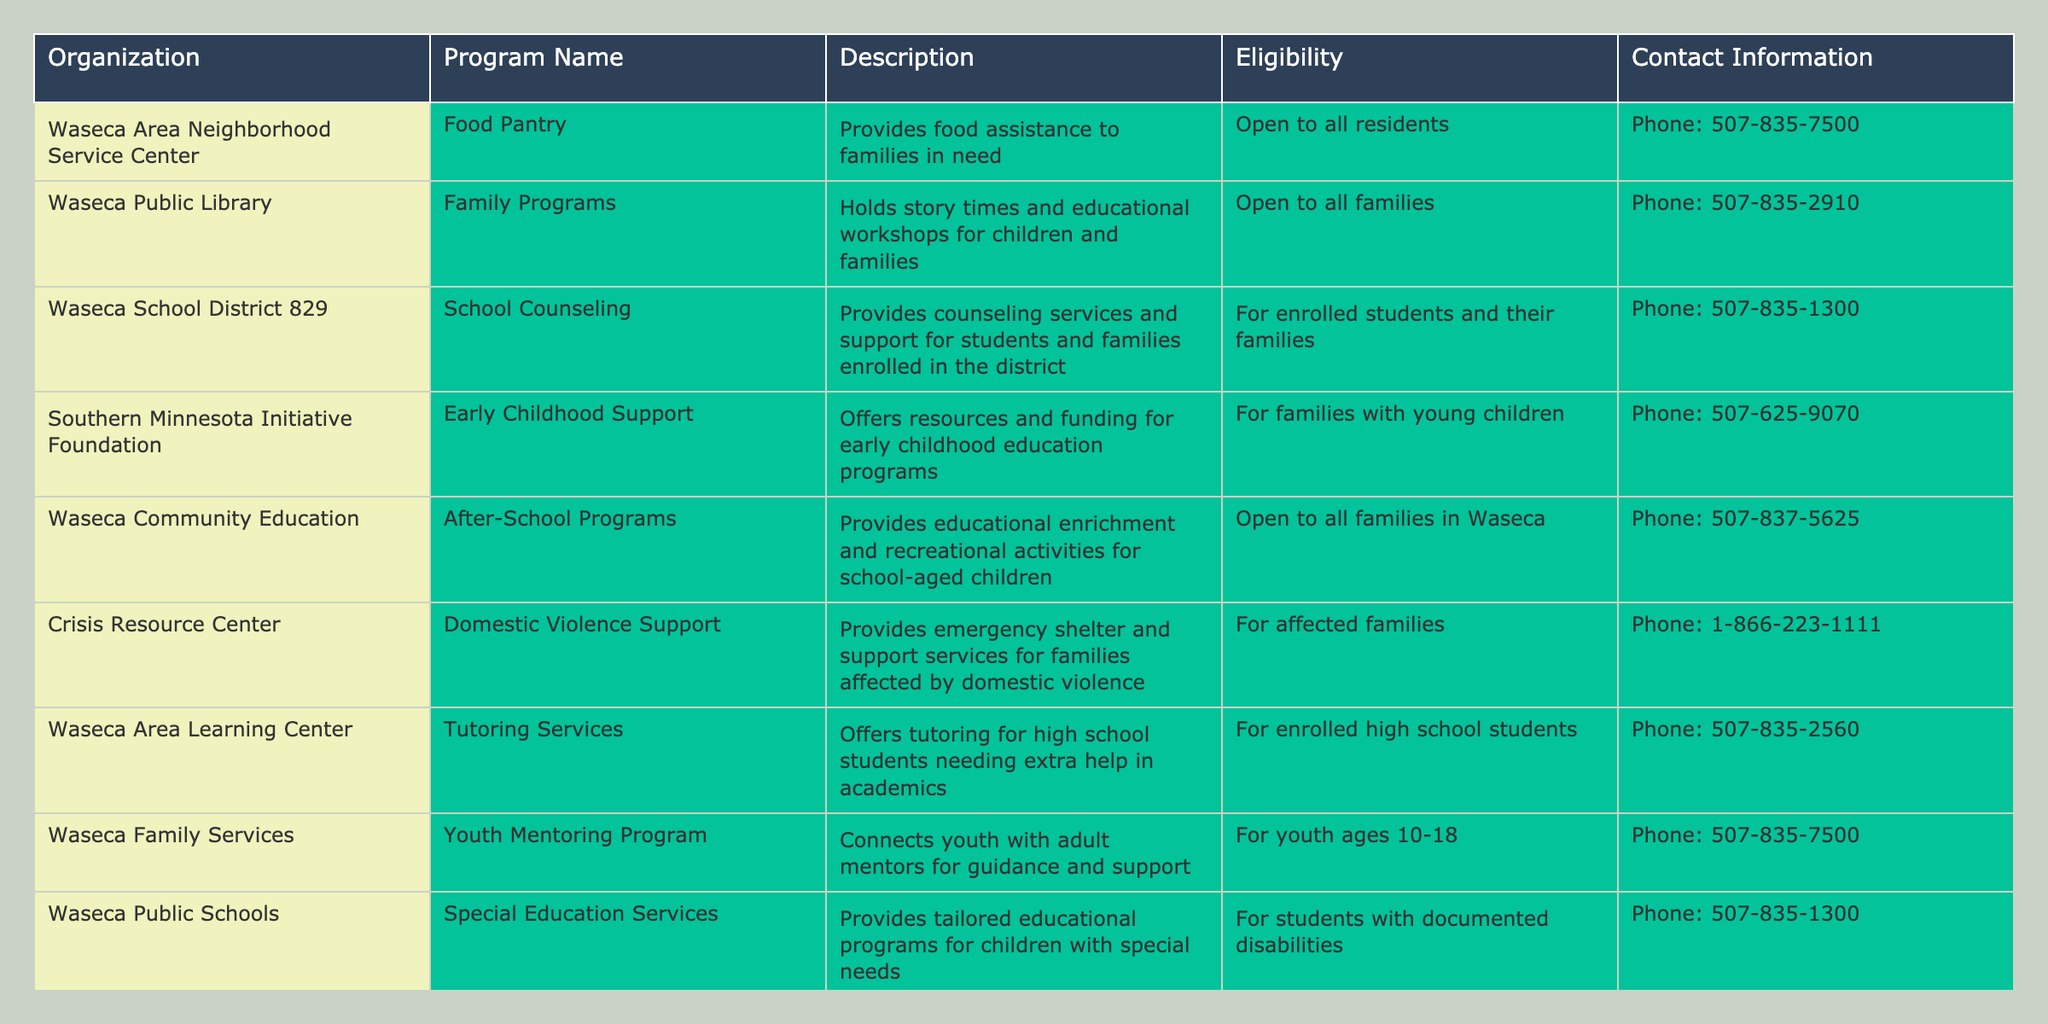What program assists families with young children in Waseca? The table lists "Early Childhood Support" offered by the Southern Minnesota Initiative Foundation, which provides resources and funding for early childhood education programs.
Answer: Early Childhood Support Is the Food Pantry available to all residents of Waseca? The table states that the Food Pantry provided by the Waseca Area Neighborhood Service Center is open to all residents, indicating inclusivity in its eligibility criteria.
Answer: Yes How many programs focus specifically on educational support for school-aged children? The table includes two programs: "After-School Programs" by Waseca Community Education and "Tutoring Services" by Waseca Area Learning Center, leading to a total of two programs focused on education for school-aged children.
Answer: 2 Does the Waseca Public Library offer programs for families? The table lists the "Family Programs" provided by Waseca Public Library, which includes story times and educational workshops for families, confirming the availability of resources for families.
Answer: Yes What contact number can families call for domestic violence support? According to the table, the Crisis Resource Center provides the contact number 1-866-223-1111 for families seeking domestic violence support services.
Answer: 1-866-223-1111 Which organizations offer counseling services for enrolled students? The table shows that Waseca School District 829 provides School Counseling services for enrolled students and their families, indicating it as the primary organization for such support.
Answer: Waseca School District 829 What percentage of the listed programs is specifically dedicated to youth mentoring? The table lists a total of 10 programs; among them, the "Youth Mentoring Program" from Waseca Family Services counts as 1 dedicated program. Thus, (1/10)*100 = 10% is the percentage dedicated to youth mentoring.
Answer: 10% Is special education assistance available for children with documented disabilities in Waseca? Yes, the table indicates that Waseca Public Schools provide Special Education Services specifically for students with documented disabilities, confirming the availability of such assistance.
Answer: Yes Which program provides tutoring for high school students and what is its contact number? The table specifies that "Tutoring Services" provided by the Waseca Area Learning Center serves high school students needing extra help, and the contact number is 507-835-2560.
Answer: Waseca Area Learning Center, 507-835-2560 How many programs are offered by organizations that explicitly mention support for domestic violence? From the table, the only program mentioning domestic violence support is provided by the Crisis Resource Center, leading to a total of one program that focuses on this issue.
Answer: 1 